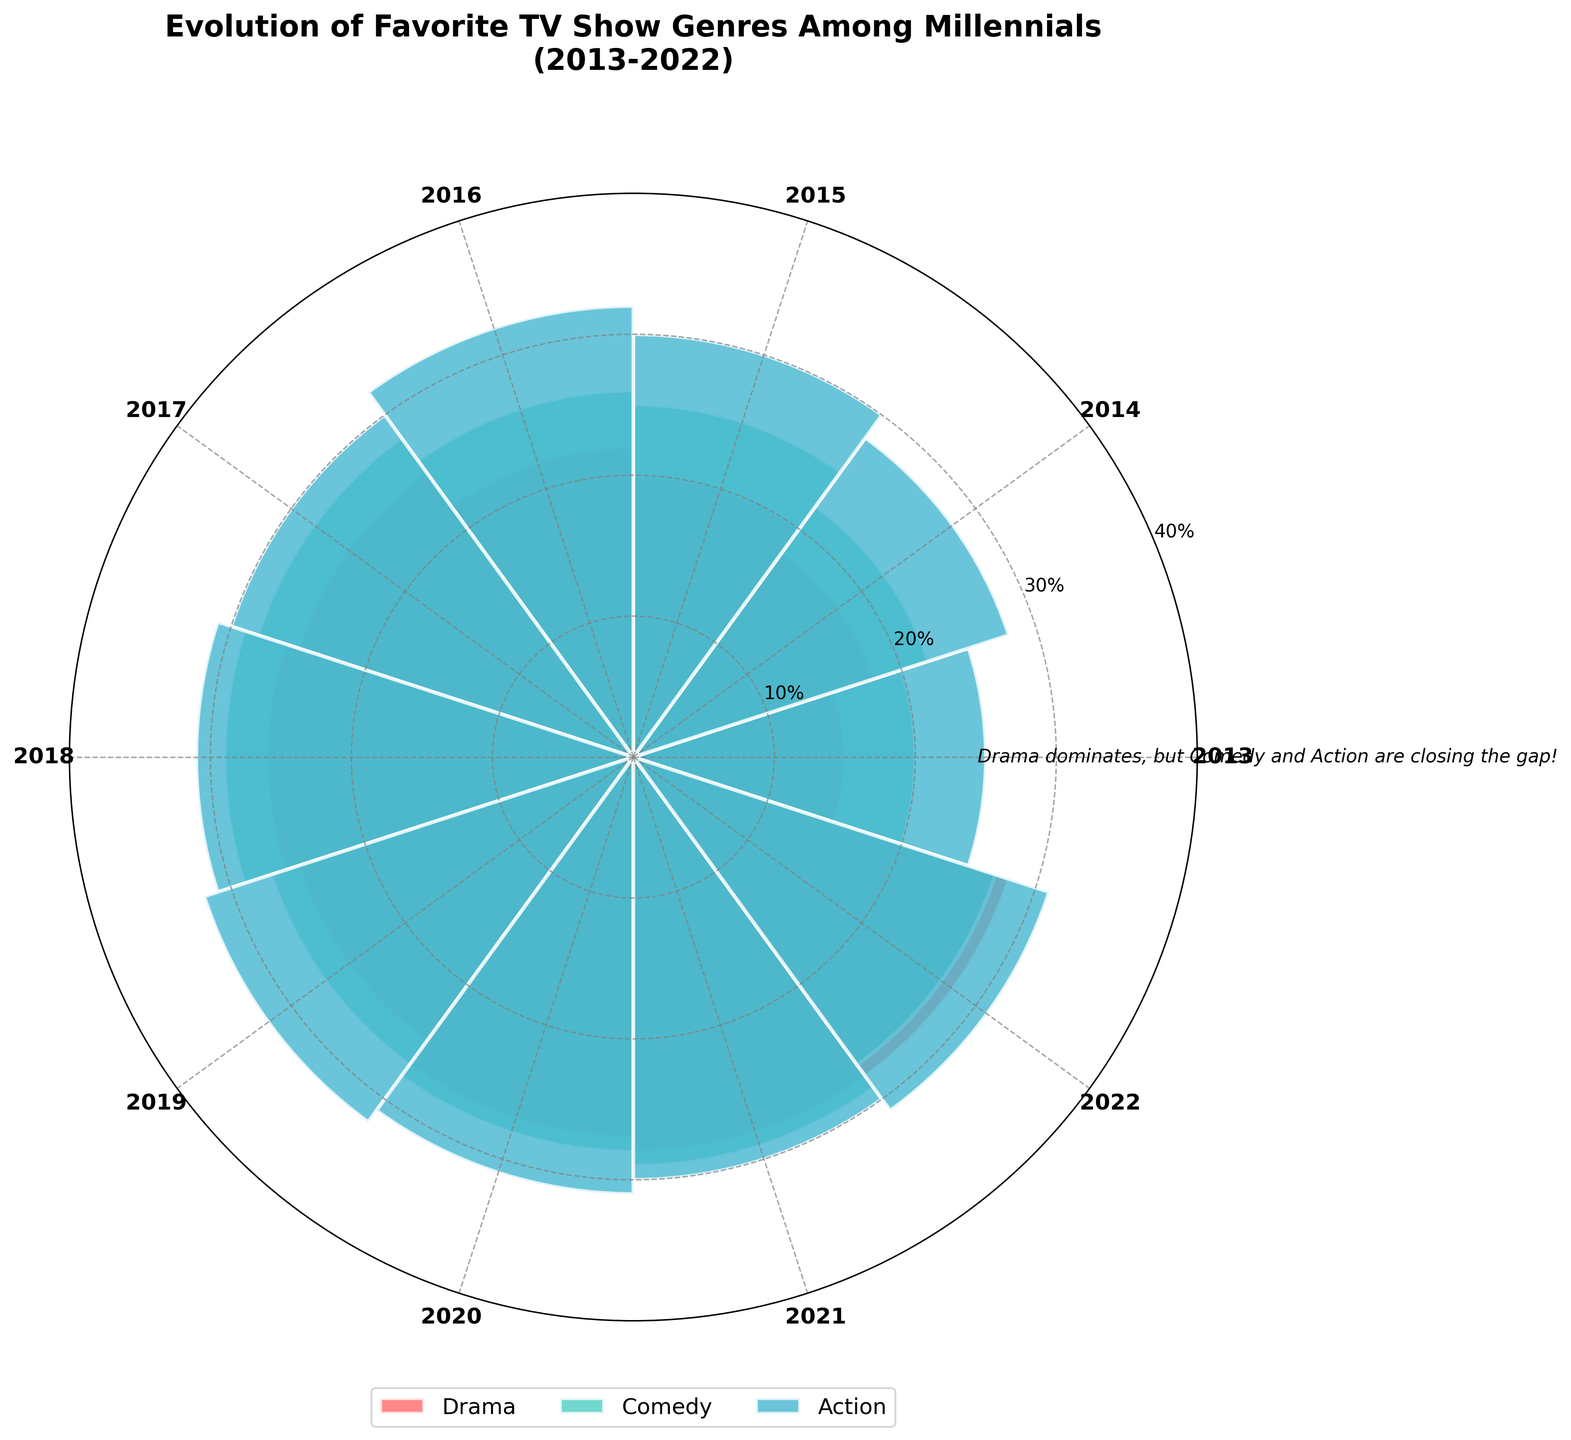What are the top 3 TV show genres depicted in the chart? The chart represents three TV show genres: Drama, Comedy, and Action, as shown by the different sections and colors in the rose chart.
Answer: Drama, Comedy, Action Which genre shows a consistent increase over the years? By examining the chart, it's clear that Drama maintains a consistently high level relative to other genres year over year.
Answer: Drama What is the trend for Comedy from 2013 to 2022? Initially, Comedy starts at 20% in 2013, rises over the years to reach its peak around 2018 at 29%, and then fluctuates slightly but generally stays high close to the 29% mark until 2022.
Answer: Increasing, then stabilizing Which year shows the highest percentage for Action? By looking at the lengths of the bars corresponding to Action (blue) for each year, in 2021 and 2022, Action reaches its highest recorded percentage of 28%.
Answer: 2021 & 2022 How much did the Drama genre increase from 2013 to 2019? In 2013, Drama accounted for 25%, and by 2019, it had increased to 32%. The difference is calculated as 32% - 25%, which is a 7% increase.
Answer: 7% In which year did Comedy surpass Drama in popularity? By comparing the lengths of the Comedy (orange) and Drama (red) bars, Comedy surpasses Drama only in 2017, with 28% for Comedy and 27% for Drama.
Answer: 2017 How does the proportion of Action in 2013 compare to 2022? The proportion of Action increases from 15% in 2013 to 28% in 2022, showing a significant growth over the years.
Answer: Increased Which genre consistently holds the second-highest percentage over the years? By visually inspecting the chart's bars, Comedy holds the second-highest percentage consistently, never dropping below Drama but staying above Action each year.
Answer: Comedy What can be inferred about millennials' TV show preferences from 2013 to 2022 based on this chart? The chart indicates that while Drama has consistently been the top genre, Comedy and Action have steadily increased in popularity, suggesting a broadening of genre preferences among millennials.
Answer: Broadening preferences 